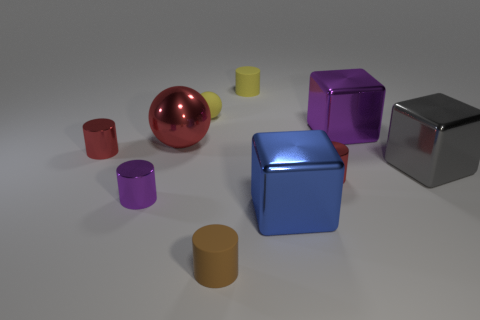Subtract all brown cylinders. How many cylinders are left? 4 Subtract all blue cylinders. Subtract all yellow blocks. How many cylinders are left? 5 Subtract all cubes. How many objects are left? 7 Subtract all red metallic objects. Subtract all rubber cylinders. How many objects are left? 5 Add 2 small spheres. How many small spheres are left? 3 Add 3 small shiny objects. How many small shiny objects exist? 6 Subtract 1 blue blocks. How many objects are left? 9 